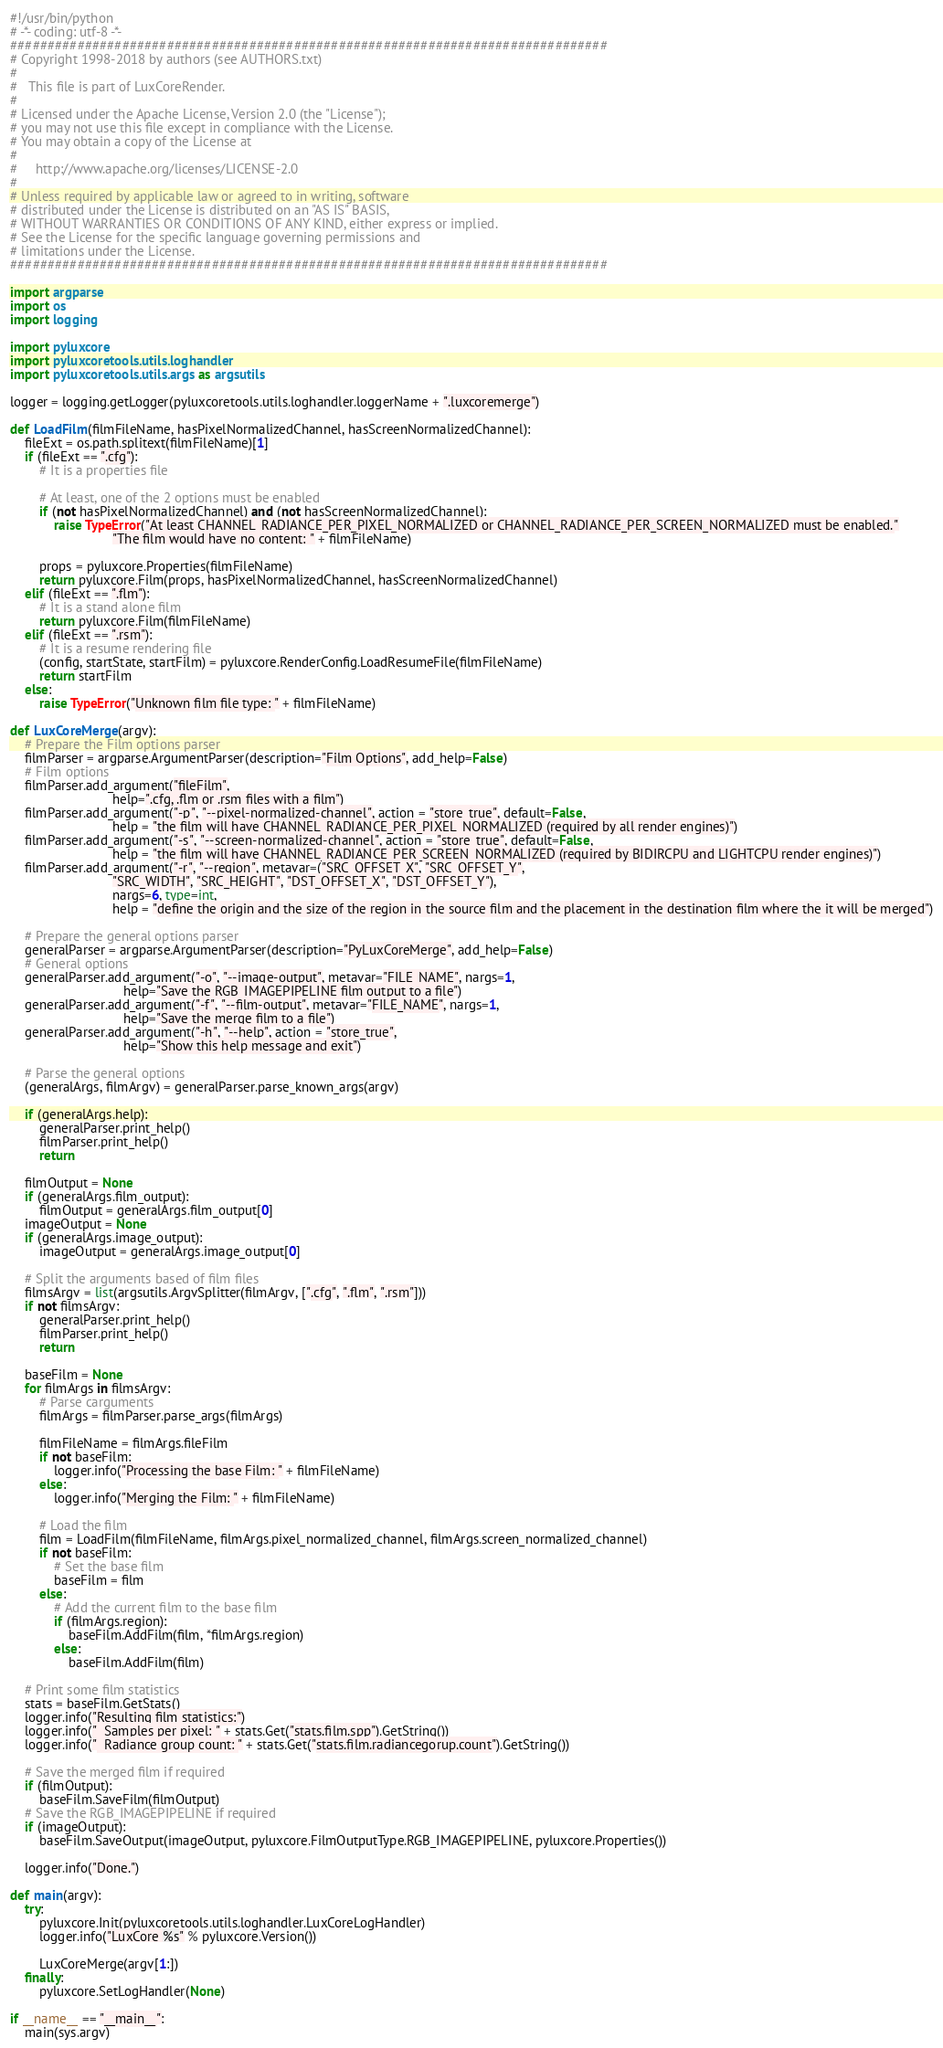Convert code to text. <code><loc_0><loc_0><loc_500><loc_500><_Python_>#!/usr/bin/python
# -*- coding: utf-8 -*-
################################################################################
# Copyright 1998-2018 by authors (see AUTHORS.txt)
#
#   This file is part of LuxCoreRender.
#
# Licensed under the Apache License, Version 2.0 (the "License");
# you may not use this file except in compliance with the License.
# You may obtain a copy of the License at
#
#     http://www.apache.org/licenses/LICENSE-2.0
#
# Unless required by applicable law or agreed to in writing, software
# distributed under the License is distributed on an "AS IS" BASIS,
# WITHOUT WARRANTIES OR CONDITIONS OF ANY KIND, either express or implied.
# See the License for the specific language governing permissions and
# limitations under the License.
################################################################################

import argparse
import os
import logging

import pyluxcore
import pyluxcoretools.utils.loghandler
import pyluxcoretools.utils.args as argsutils

logger = logging.getLogger(pyluxcoretools.utils.loghandler.loggerName + ".luxcoremerge")

def LoadFilm(filmFileName, hasPixelNormalizedChannel, hasScreenNormalizedChannel):
	fileExt = os.path.splitext(filmFileName)[1]
	if (fileExt == ".cfg"):
		# It is a properties file

		# At least, one of the 2 options must be enabled
		if (not hasPixelNormalizedChannel) and (not hasScreenNormalizedChannel):
			raise TypeError("At least CHANNEL_RADIANCE_PER_PIXEL_NORMALIZED or CHANNEL_RADIANCE_PER_SCREEN_NORMALIZED must be enabled."
							"The film would have no content: " + filmFileName)

		props = pyluxcore.Properties(filmFileName)
		return pyluxcore.Film(props, hasPixelNormalizedChannel, hasScreenNormalizedChannel)
	elif (fileExt == ".flm"):
		# It is a stand alone film
		return pyluxcore.Film(filmFileName)
	elif (fileExt == ".rsm"):
		# It is a resume rendering file
		(config, startState, startFilm) = pyluxcore.RenderConfig.LoadResumeFile(filmFileName)
		return startFilm
	else:
		raise TypeError("Unknown film file type: " + filmFileName)

def LuxCoreMerge(argv):
	# Prepare the Film options parser
	filmParser = argparse.ArgumentParser(description="Film Options", add_help=False)
	# Film options
	filmParser.add_argument("fileFilm",
							help=".cfg, .flm or .rsm files with a film")
	filmParser.add_argument("-p", "--pixel-normalized-channel", action = "store_true", default=False,
							help = "the film will have CHANNEL_RADIANCE_PER_PIXEL_NORMALIZED (required by all render engines)")
	filmParser.add_argument("-s", "--screen-normalized-channel", action = "store_true", default=False,
							help = "the film will have CHANNEL_RADIANCE_PER_SCREEN_NORMALIZED (required by BIDIRCPU and LIGHTCPU render engines)")
	filmParser.add_argument("-r", "--region", metavar=("SRC_OFFSET_X", "SRC_OFFSET_Y",
							"SRC_WIDTH", "SRC_HEIGHT", "DST_OFFSET_X", "DST_OFFSET_Y"),
							nargs=6, type=int,
							help = "define the origin and the size of the region in the source film and the placement in the destination film where the it will be merged")

	# Prepare the general options parser
	generalParser = argparse.ArgumentParser(description="PyLuxCoreMerge", add_help=False)
	# General options
	generalParser.add_argument("-o", "--image-output", metavar="FILE_NAME", nargs=1,
							   help="Save the RGB_IMAGEPIPELINE film output to a file")
	generalParser.add_argument("-f", "--film-output", metavar="FILE_NAME", nargs=1,
							   help="Save the merge film to a file")
	generalParser.add_argument("-h", "--help", action = "store_true",
							   help="Show this help message and exit")

	# Parse the general options
	(generalArgs, filmArgv) = generalParser.parse_known_args(argv)

	if (generalArgs.help):
		generalParser.print_help()
		filmParser.print_help()
		return

	filmOutput = None
	if (generalArgs.film_output):
		filmOutput = generalArgs.film_output[0]
	imageOutput = None
	if (generalArgs.image_output):
		imageOutput = generalArgs.image_output[0]

	# Split the arguments based of film files
	filmsArgv = list(argsutils.ArgvSplitter(filmArgv, [".cfg", ".flm", ".rsm"]))
	if not filmsArgv:
		generalParser.print_help()
		filmParser.print_help()
		return

	baseFilm = None
	for filmArgs in filmsArgv:
		# Parse carguments
		filmArgs = filmParser.parse_args(filmArgs)

		filmFileName = filmArgs.fileFilm
		if not baseFilm:
			logger.info("Processing the base Film: " + filmFileName)
		else:
			logger.info("Merging the Film: " + filmFileName)
		
		# Load the film
		film = LoadFilm(filmFileName, filmArgs.pixel_normalized_channel, filmArgs.screen_normalized_channel)
		if not baseFilm:
			# Set the base film
			baseFilm = film
		else:
			# Add the current film to the base film
			if (filmArgs.region):
				baseFilm.AddFilm(film, *filmArgs.region)
			else:
				baseFilm.AddFilm(film)

	# Print some film statistics
	stats = baseFilm.GetStats()
	logger.info("Resulting film statistics:")
	logger.info("  Samples per pixel: " + stats.Get("stats.film.spp").GetString())
	logger.info("  Radiance group count: " + stats.Get("stats.film.radiancegorup.count").GetString())

	# Save the merged film if required
	if (filmOutput):
		baseFilm.SaveFilm(filmOutput)
	# Save the RGB_IMAGEPIPELINE if required
	if (imageOutput):
		baseFilm.SaveOutput(imageOutput, pyluxcore.FilmOutputType.RGB_IMAGEPIPELINE, pyluxcore.Properties())

	logger.info("Done.")

def main(argv):
	try:
		pyluxcore.Init(pyluxcoretools.utils.loghandler.LuxCoreLogHandler)
		logger.info("LuxCore %s" % pyluxcore.Version())

		LuxCoreMerge(argv[1:])
	finally:
		pyluxcore.SetLogHandler(None)

if __name__ == "__main__":
	main(sys.argv)
</code> 